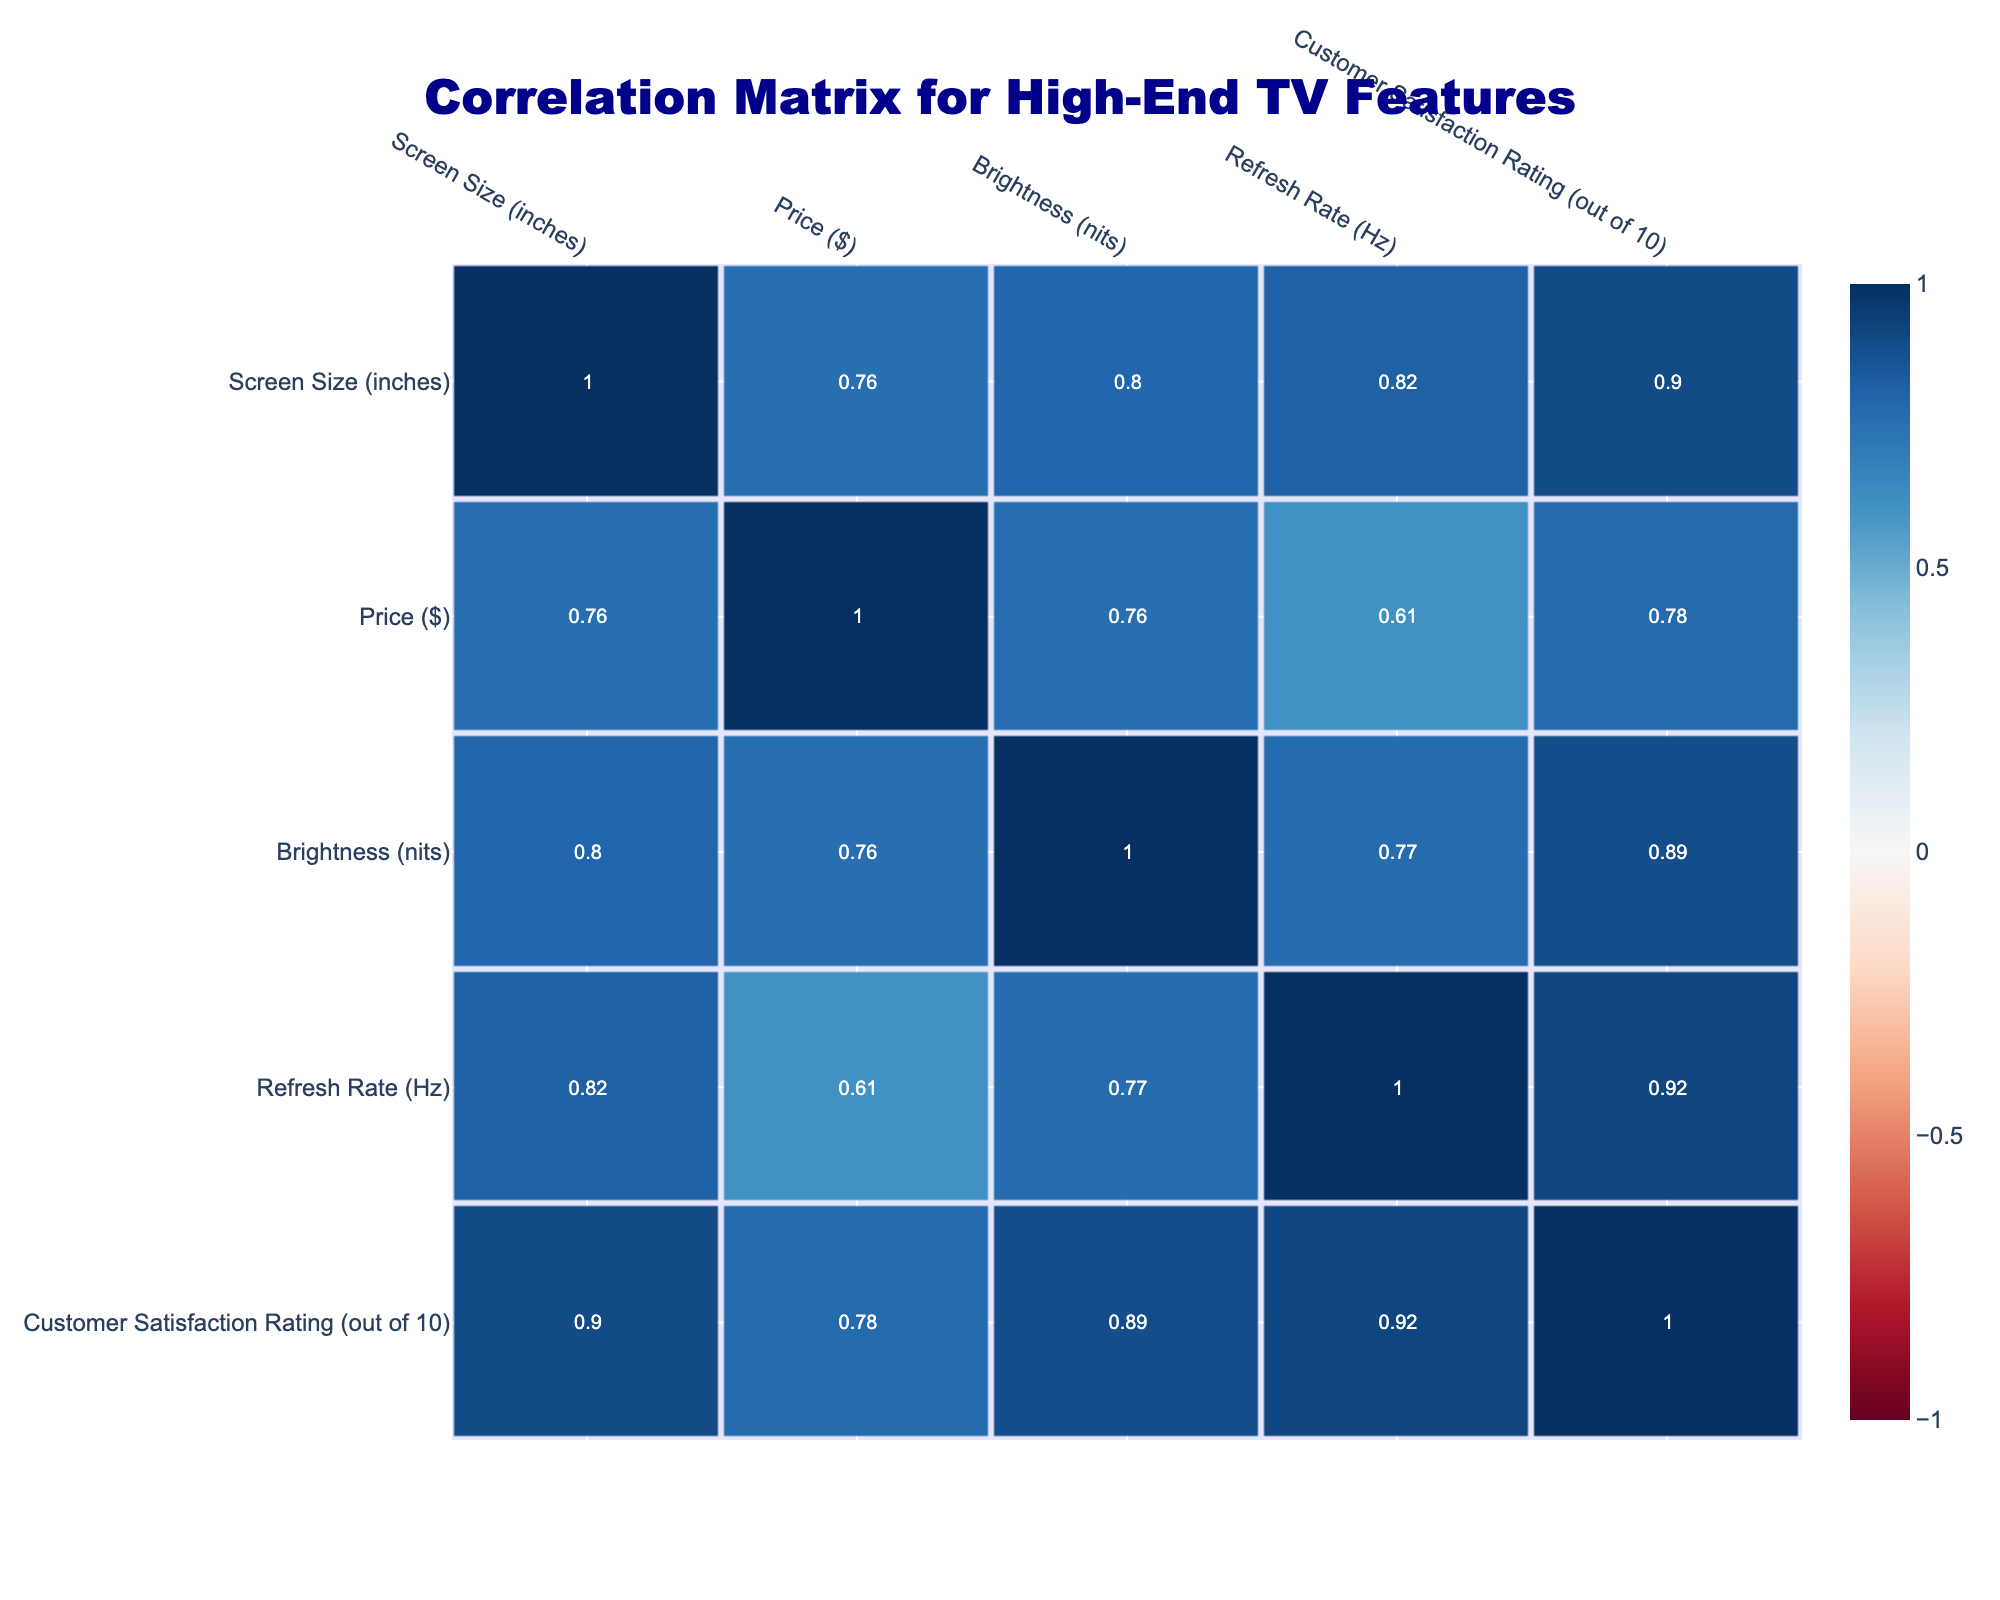What is the customer satisfaction rating of the Samsung QN900B? The table shows that the Samsung QN900B has a customer satisfaction rating of 9.1 out of 10.
Answer: 9.1 How many models have a customer satisfaction rating above 8.5? By examining the customer satisfaction ratings in the table, the Samsung QN900B (9.1), QN90B (8.8), and QN85B (8.6) from Samsung and the Sony A95K OLED (8.7) from Sony, making a total of 4 models with ratings above 8.5.
Answer: 4 What is the average customer satisfaction rating for LG models? The customer satisfaction ratings for LG models are 8.5 for the C2 OLED and 8.4 for the G2 OLED. Adding these ratings together gives 8.5 + 8.4 = 16.9, and dividing by the number of models (2) results in an average of 16.9/2 = 8.45.
Answer: 8.45 Is the Samsung QN90B rated higher than the Sony X90K? The table shows that the Samsung QN90B has a rating of 8.8, while the Sony X90K has a rating of 8.3. Since 8.8 is greater than 8.3, the answer is yes.
Answer: Yes Which brand has the highest customer satisfaction rating among all listed models? The highest rating in the table is from the Samsung QN900B with a score of 9.1, which is greater than all other models. Therefore, the brand with the highest rating is Samsung.
Answer: Samsung 